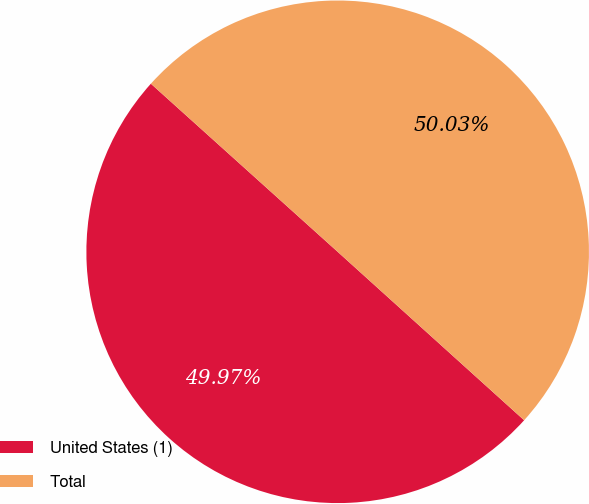Convert chart. <chart><loc_0><loc_0><loc_500><loc_500><pie_chart><fcel>United States (1)<fcel>Total<nl><fcel>49.97%<fcel>50.03%<nl></chart> 